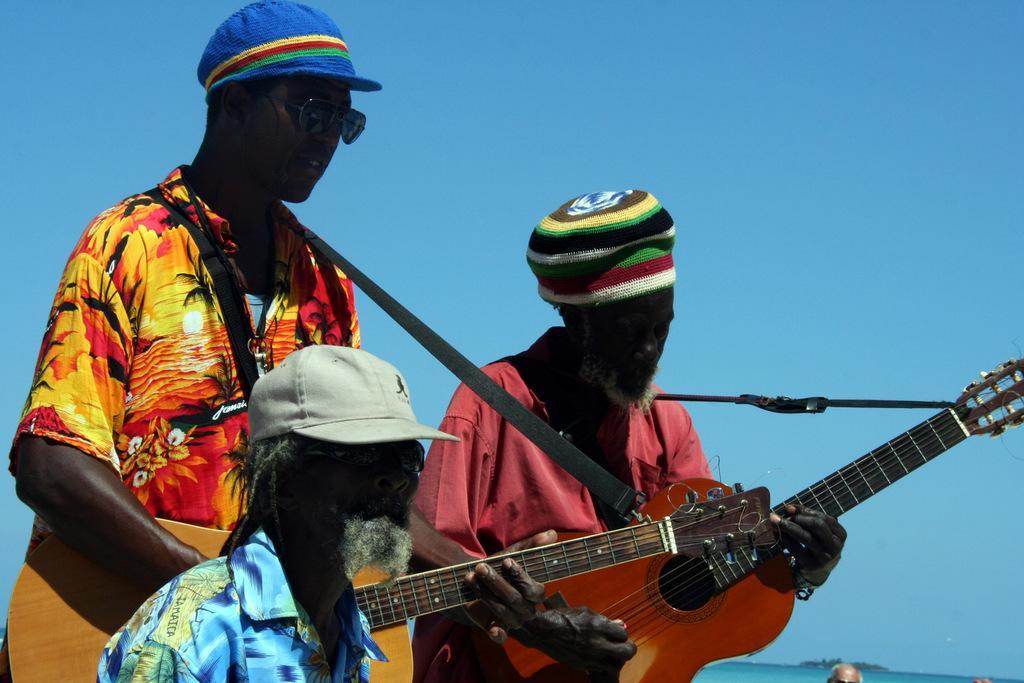Can you describe this image briefly? In this image I see 3 men and all of them wearing caps, in which this 2 are holding the guitars. In the background I see the sky and a person over here. 